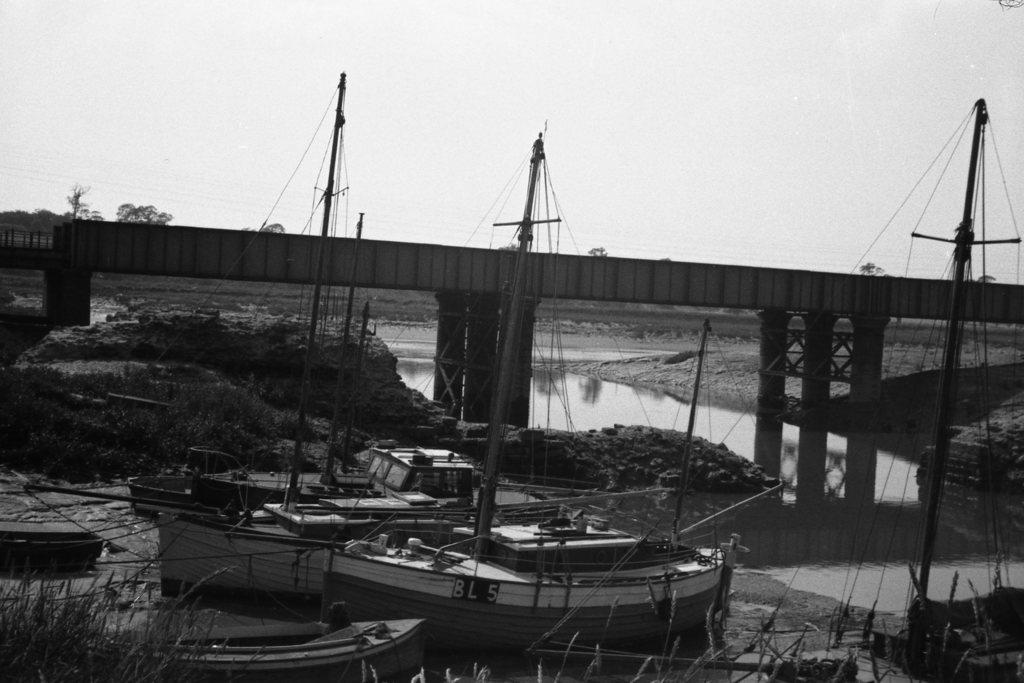What type of boats are in the image? There are triremes in the image. What is the primary setting of the image? There is water in the image. What architectural feature is present in the image? There is a bridge in the image. What type of vegetation can be seen in the background of the image? There are trees in the background of the image. What is visible at the top of the image? The sky is visible at the top of the image. What type of pets can be seen playing with bait in the image? There are no pets or bait present in the image; it features triremes, water, a bridge, trees, and the sky. 